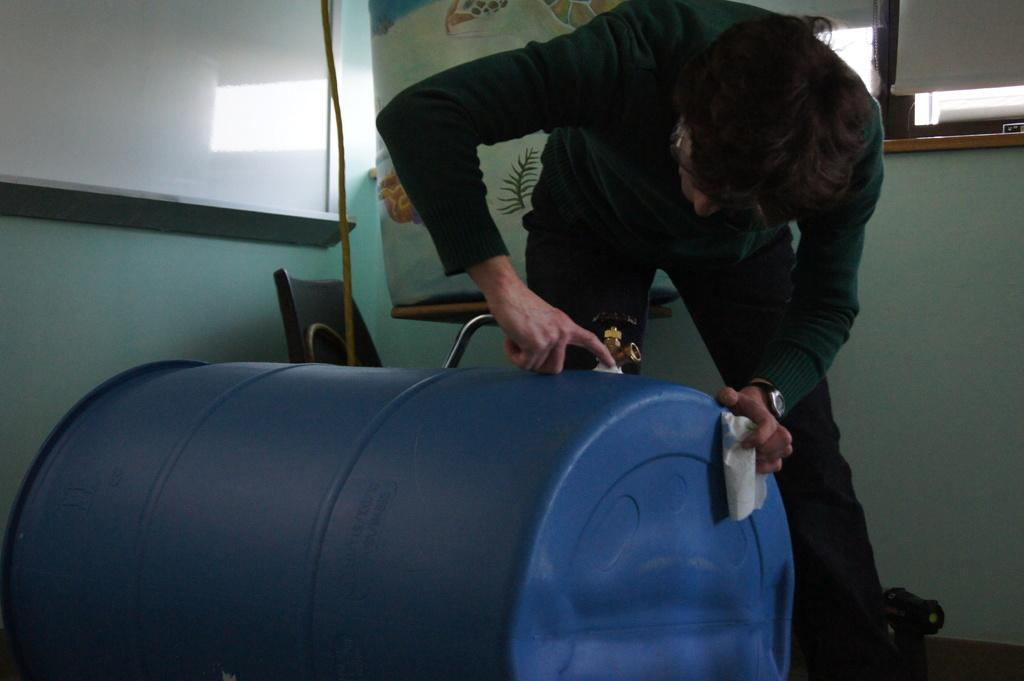Who is the main subject in the image? There is a man in the center of the image. What is the man doing in the image? The man is repairing a drum. What can be seen in the background of the image? There is a window, a board, a chair, and a wall in the background of the image. What type of company is responsible for the smoke in the image? There is no smoke present in the image, so it is not possible to determine which company might be responsible. 